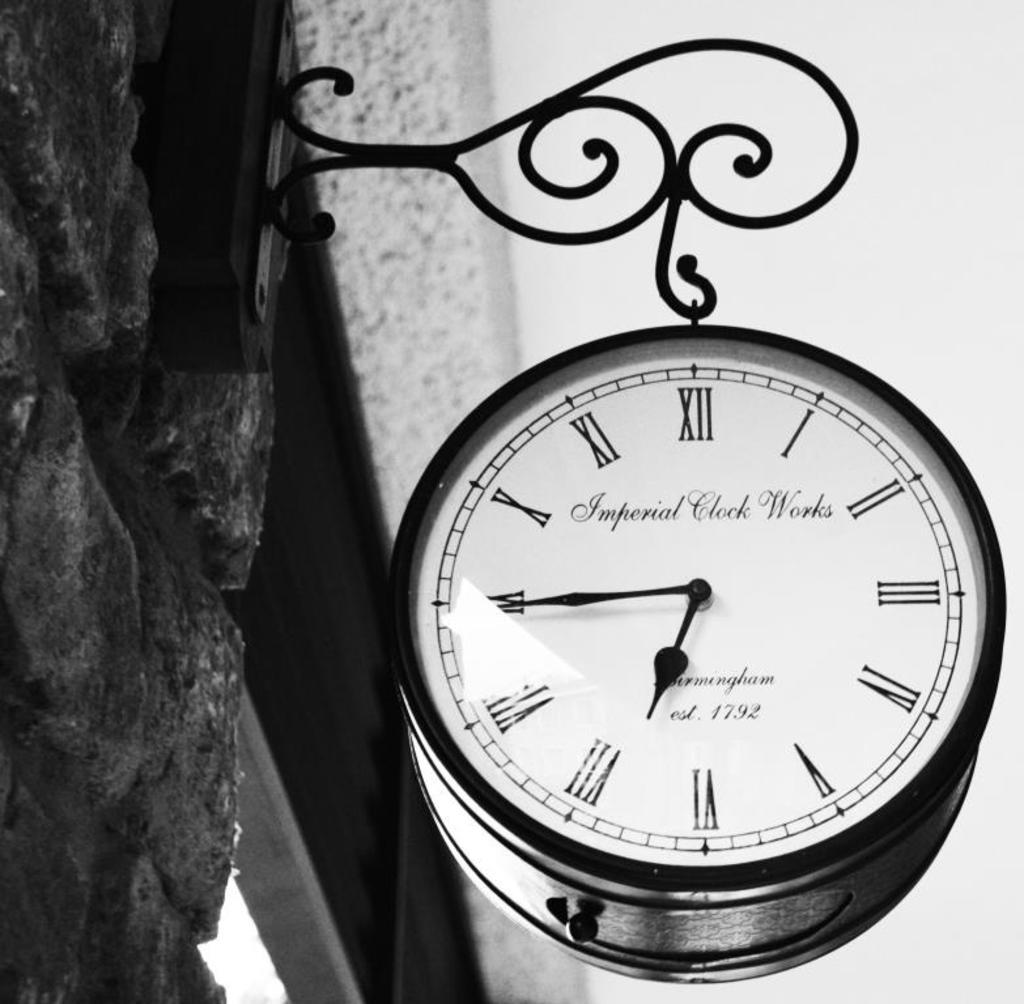Provide a one-sentence caption for the provided image. A clock hanging from a building made by Imperial Clock Works. 